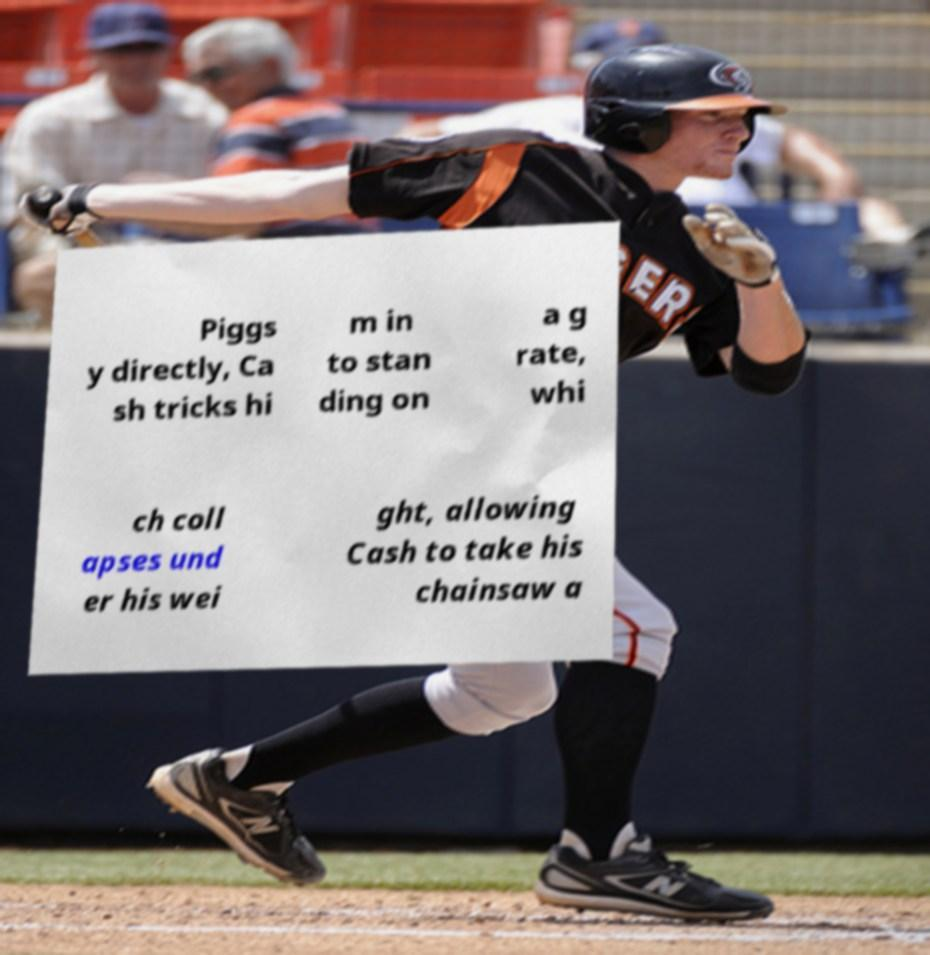For documentation purposes, I need the text within this image transcribed. Could you provide that? Piggs y directly, Ca sh tricks hi m in to stan ding on a g rate, whi ch coll apses und er his wei ght, allowing Cash to take his chainsaw a 